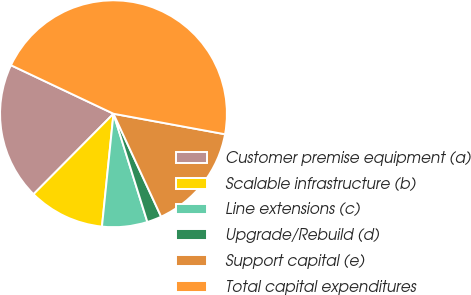Convert chart. <chart><loc_0><loc_0><loc_500><loc_500><pie_chart><fcel>Customer premise equipment (a)<fcel>Scalable infrastructure (b)<fcel>Line extensions (c)<fcel>Upgrade/Rebuild (d)<fcel>Support capital (e)<fcel>Total capital expenditures<nl><fcel>19.59%<fcel>10.83%<fcel>6.45%<fcel>2.07%<fcel>15.21%<fcel>45.87%<nl></chart> 